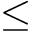<formula> <loc_0><loc_0><loc_500><loc_500>\leq</formula> 